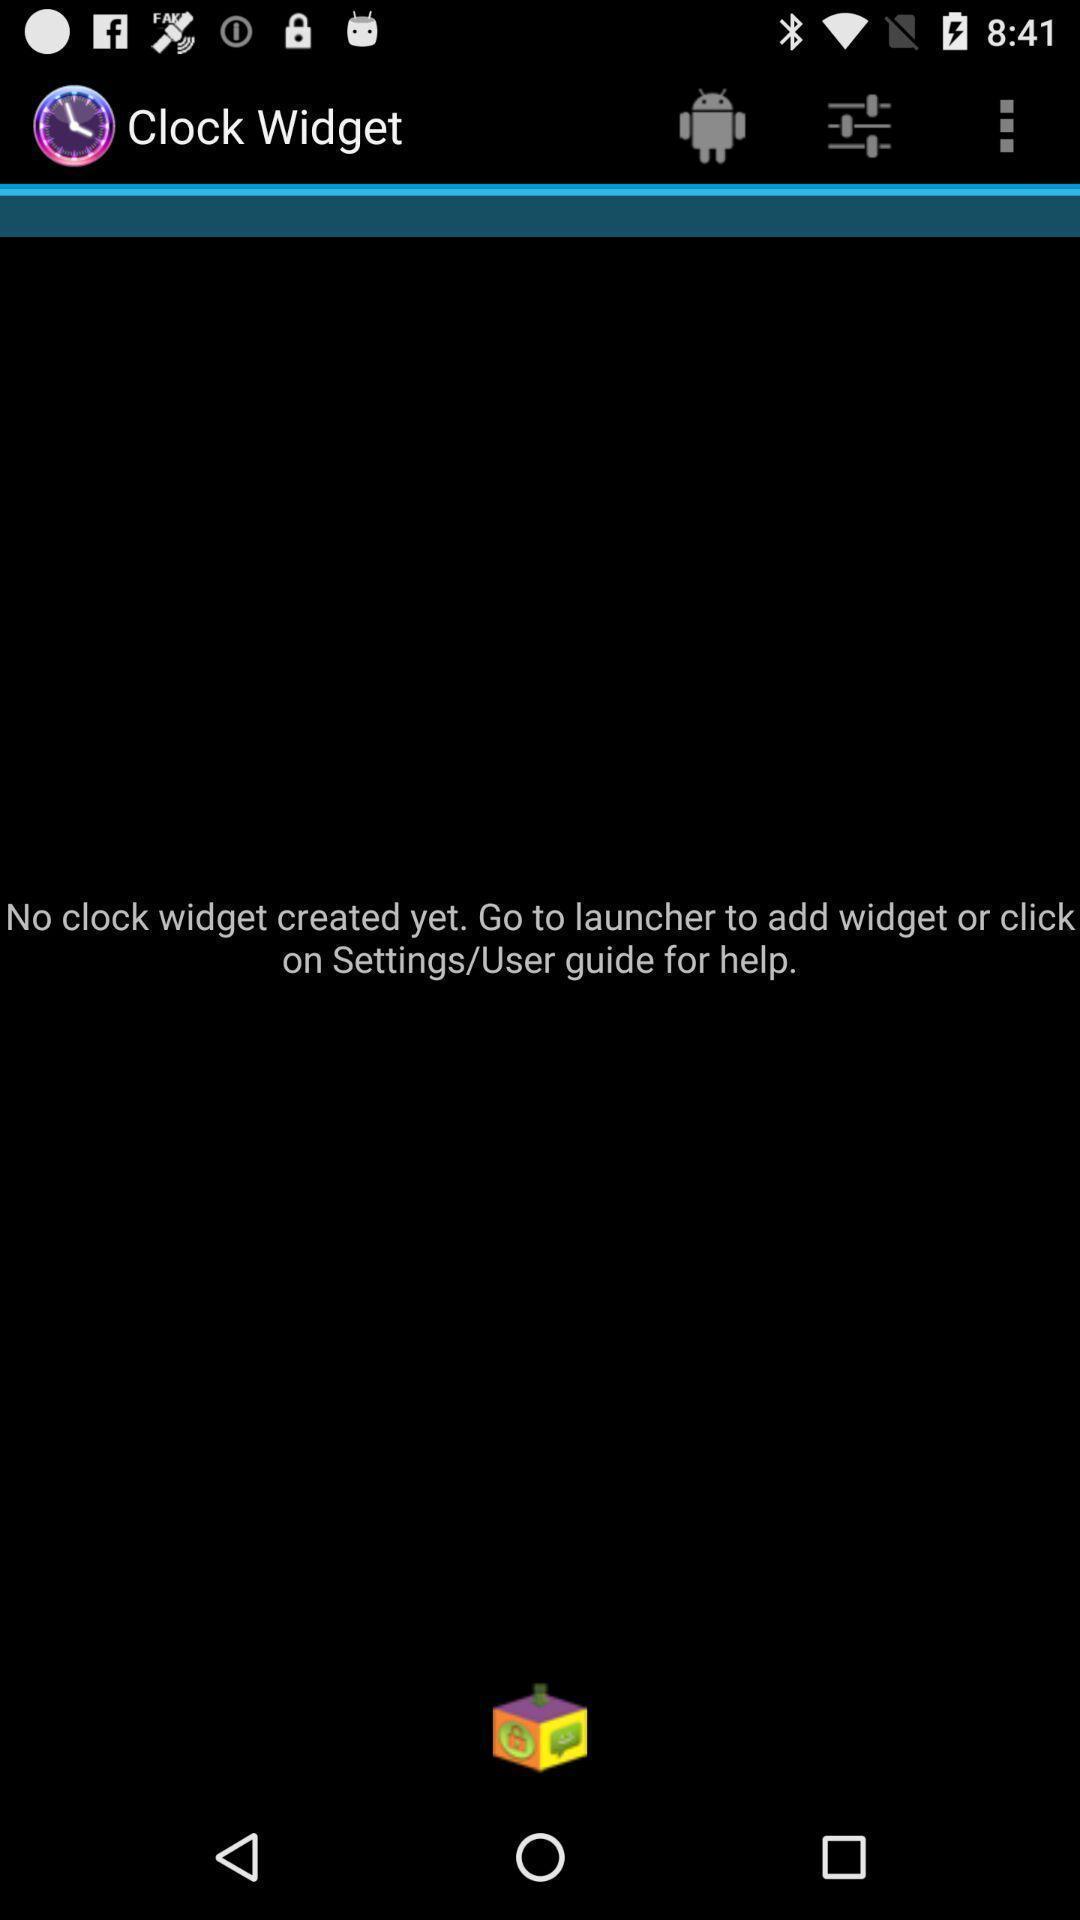Describe the key features of this screenshot. Page showing information about widget. 